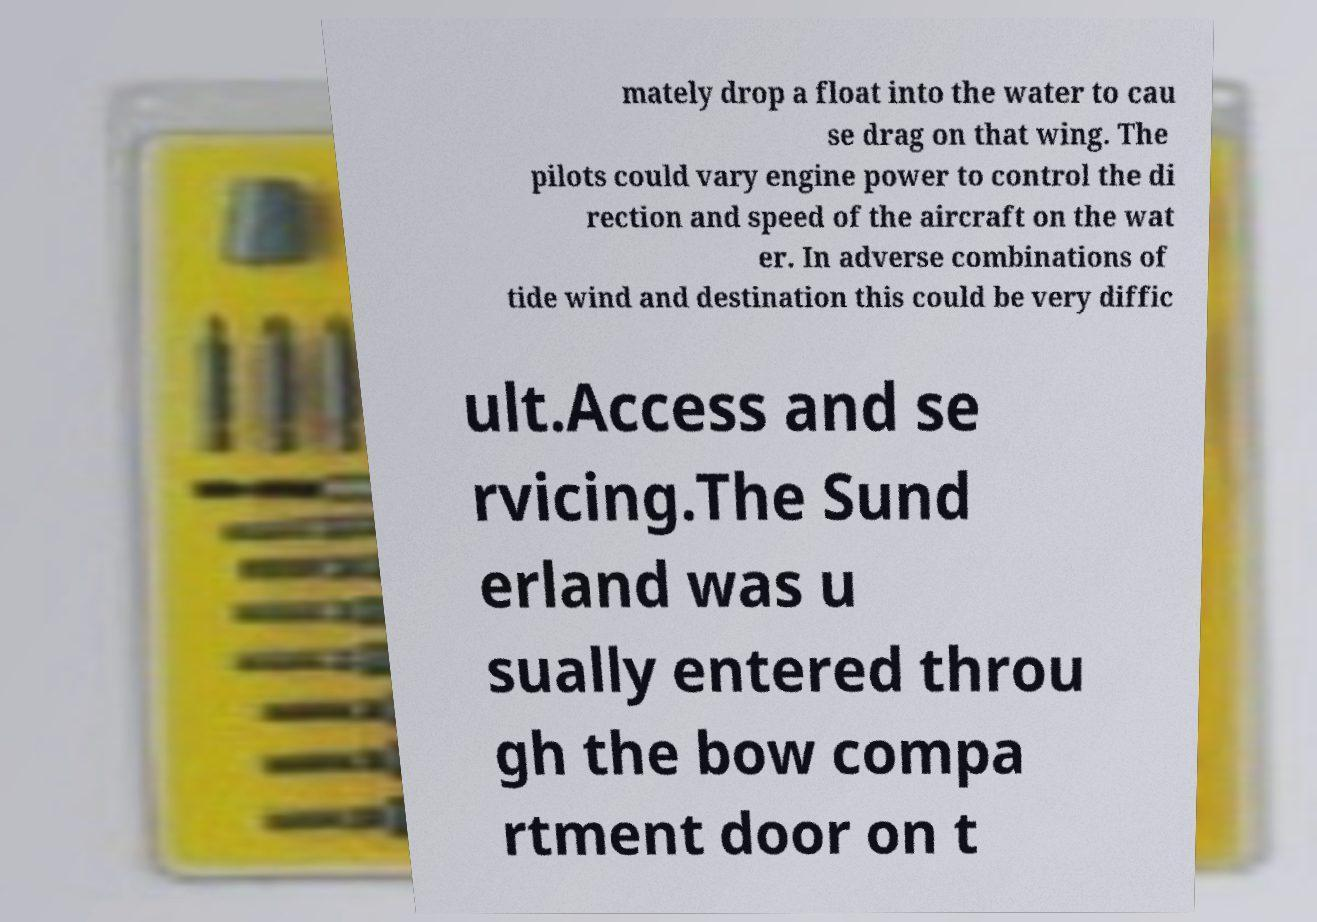For documentation purposes, I need the text within this image transcribed. Could you provide that? mately drop a float into the water to cau se drag on that wing. The pilots could vary engine power to control the di rection and speed of the aircraft on the wat er. In adverse combinations of tide wind and destination this could be very diffic ult.Access and se rvicing.The Sund erland was u sually entered throu gh the bow compa rtment door on t 